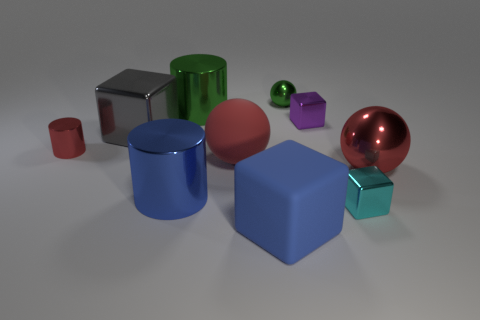There is a metal block that is to the right of the large blue rubber object and behind the cyan metallic block; what color is it?
Make the answer very short. Purple. Is the number of blue things that are on the right side of the big blue shiny cylinder greater than the number of purple cubes that are to the left of the small red metal cylinder?
Keep it short and to the point. Yes. What size is the red cylinder that is made of the same material as the blue cylinder?
Provide a short and direct response. Small. How many cyan shiny cubes are left of the large block that is right of the big green metal thing?
Provide a short and direct response. 0. Are there any red matte objects of the same shape as the gray object?
Give a very brief answer. No. There is a big shiny cylinder in front of the big rubber thing that is behind the large blue block; what color is it?
Offer a terse response. Blue. Is the number of large green cubes greater than the number of large red spheres?
Your response must be concise. No. What number of purple blocks have the same size as the green sphere?
Make the answer very short. 1. Do the large blue cube and the cube that is to the left of the big blue rubber cube have the same material?
Keep it short and to the point. No. Are there fewer matte spheres than green objects?
Provide a short and direct response. Yes. 